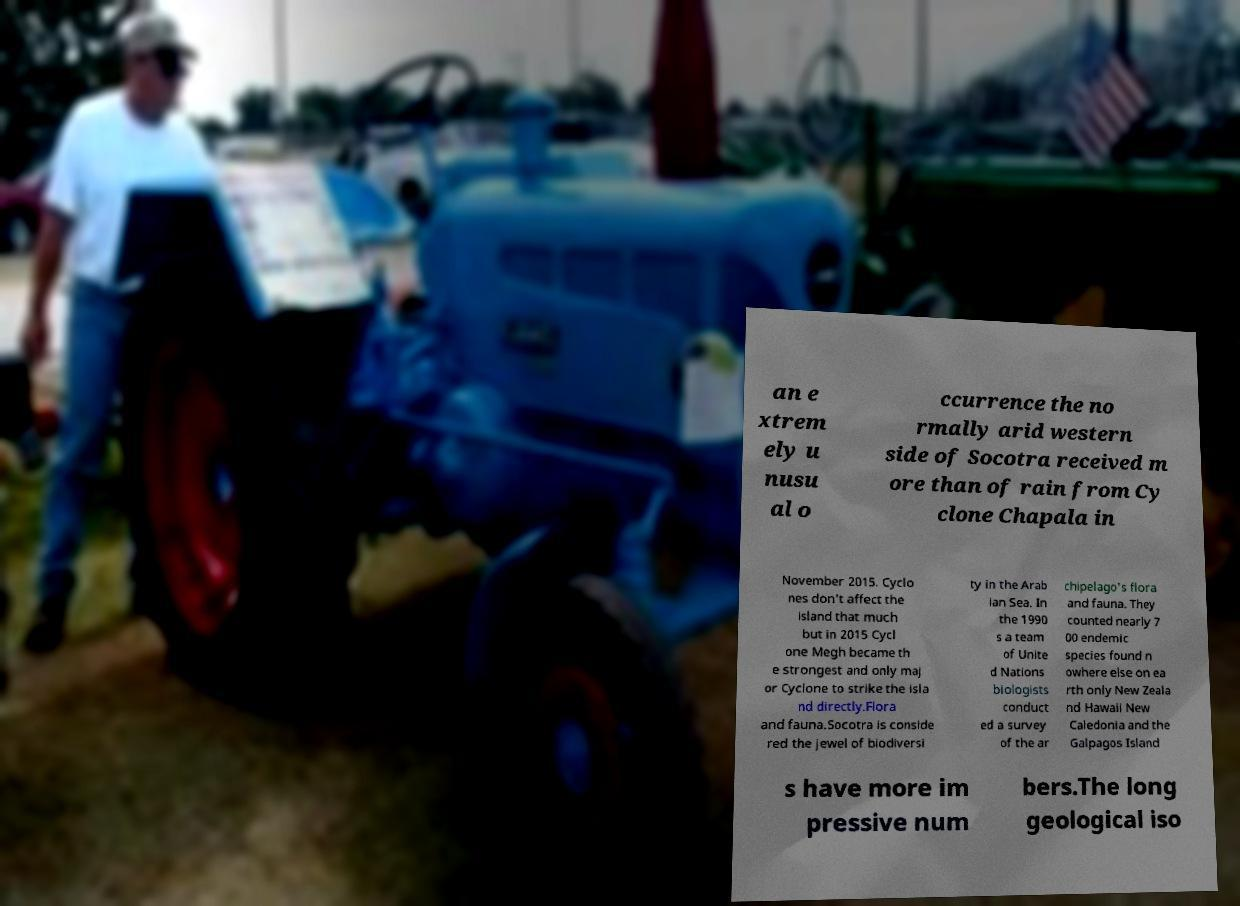Could you extract and type out the text from this image? an e xtrem ely u nusu al o ccurrence the no rmally arid western side of Socotra received m ore than of rain from Cy clone Chapala in November 2015. Cyclo nes don't affect the island that much but in 2015 Cycl one Megh became th e strongest and only maj or Cyclone to strike the isla nd directly.Flora and fauna.Socotra is conside red the jewel of biodiversi ty in the Arab ian Sea. In the 1990 s a team of Unite d Nations biologists conduct ed a survey of the ar chipelago's flora and fauna. They counted nearly 7 00 endemic species found n owhere else on ea rth only New Zeala nd Hawaii New Caledonia and the Galpagos Island s have more im pressive num bers.The long geological iso 